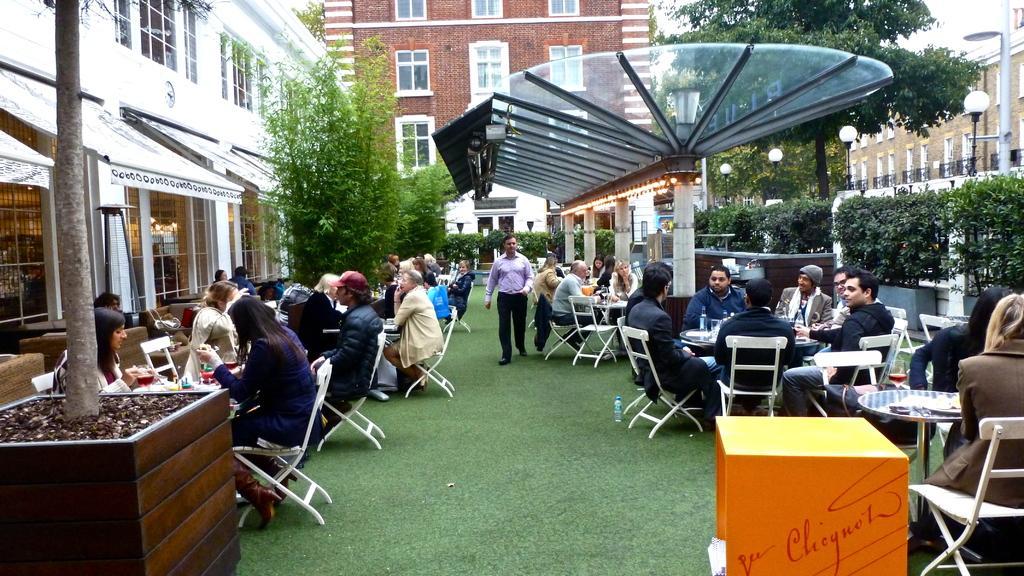Can you describe this image briefly? In this picture we can see some group of people sitting on the chair around the table and there are some plants around them. 